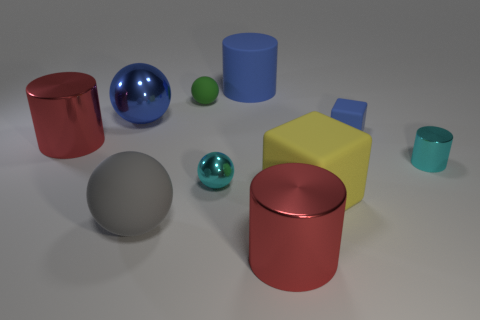Subtract all purple cubes. How many red cylinders are left? 2 Subtract all green rubber spheres. How many spheres are left? 3 Subtract all cyan cylinders. How many cylinders are left? 3 Subtract 1 cylinders. How many cylinders are left? 3 Subtract all gray cylinders. Subtract all gray blocks. How many cylinders are left? 4 Subtract all balls. How many objects are left? 6 Subtract 0 purple cubes. How many objects are left? 10 Subtract all green balls. Subtract all blue objects. How many objects are left? 6 Add 4 rubber objects. How many rubber objects are left? 9 Add 5 large gray metal balls. How many large gray metal balls exist? 5 